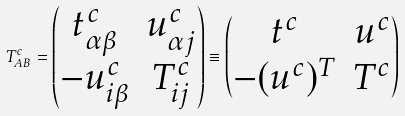Convert formula to latex. <formula><loc_0><loc_0><loc_500><loc_500>T ^ { c } _ { A B } = \begin{pmatrix} t ^ { c } _ { \alpha \beta } & u ^ { c } _ { \alpha j } \\ - u ^ { c } _ { i \beta } & T ^ { c } _ { i j } \end{pmatrix} \equiv \begin{pmatrix} t ^ { c } & u ^ { c } \\ - ( u ^ { c } ) ^ { T } & T ^ { c } \end{pmatrix}</formula> 